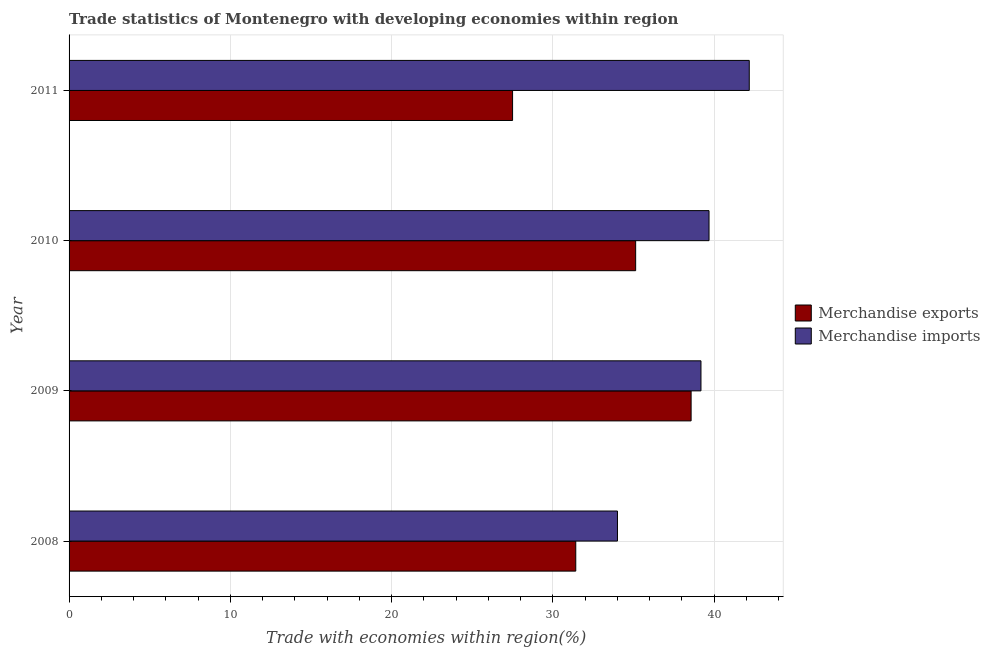How many groups of bars are there?
Ensure brevity in your answer.  4. Are the number of bars per tick equal to the number of legend labels?
Keep it short and to the point. Yes. In how many cases, is the number of bars for a given year not equal to the number of legend labels?
Keep it short and to the point. 0. What is the merchandise imports in 2008?
Your response must be concise. 34. Across all years, what is the maximum merchandise exports?
Your answer should be very brief. 38.57. Across all years, what is the minimum merchandise exports?
Make the answer very short. 27.5. In which year was the merchandise exports maximum?
Your answer should be compact. 2009. What is the total merchandise exports in the graph?
Your answer should be very brief. 132.61. What is the difference between the merchandise exports in 2008 and that in 2009?
Your response must be concise. -7.15. What is the difference between the merchandise imports in 2008 and the merchandise exports in 2010?
Your response must be concise. -1.13. What is the average merchandise exports per year?
Give a very brief answer. 33.15. In the year 2009, what is the difference between the merchandise imports and merchandise exports?
Offer a terse response. 0.61. In how many years, is the merchandise imports greater than 6 %?
Keep it short and to the point. 4. What is the ratio of the merchandise imports in 2010 to that in 2011?
Your answer should be very brief. 0.94. Is the difference between the merchandise exports in 2008 and 2009 greater than the difference between the merchandise imports in 2008 and 2009?
Provide a short and direct response. No. What is the difference between the highest and the second highest merchandise imports?
Ensure brevity in your answer.  2.5. What is the difference between the highest and the lowest merchandise exports?
Keep it short and to the point. 11.07. How many bars are there?
Provide a short and direct response. 8. How many years are there in the graph?
Make the answer very short. 4. What is the difference between two consecutive major ticks on the X-axis?
Your answer should be very brief. 10. Where does the legend appear in the graph?
Your answer should be compact. Center right. How many legend labels are there?
Ensure brevity in your answer.  2. What is the title of the graph?
Give a very brief answer. Trade statistics of Montenegro with developing economies within region. Does "Goods and services" appear as one of the legend labels in the graph?
Your answer should be very brief. No. What is the label or title of the X-axis?
Ensure brevity in your answer.  Trade with economies within region(%). What is the label or title of the Y-axis?
Provide a succinct answer. Year. What is the Trade with economies within region(%) of Merchandise exports in 2008?
Provide a succinct answer. 31.42. What is the Trade with economies within region(%) in Merchandise imports in 2008?
Give a very brief answer. 34. What is the Trade with economies within region(%) in Merchandise exports in 2009?
Provide a succinct answer. 38.57. What is the Trade with economies within region(%) in Merchandise imports in 2009?
Make the answer very short. 39.18. What is the Trade with economies within region(%) in Merchandise exports in 2010?
Offer a terse response. 35.13. What is the Trade with economies within region(%) in Merchandise imports in 2010?
Offer a terse response. 39.68. What is the Trade with economies within region(%) in Merchandise exports in 2011?
Your answer should be very brief. 27.5. What is the Trade with economies within region(%) in Merchandise imports in 2011?
Your answer should be compact. 42.17. Across all years, what is the maximum Trade with economies within region(%) of Merchandise exports?
Provide a succinct answer. 38.57. Across all years, what is the maximum Trade with economies within region(%) of Merchandise imports?
Make the answer very short. 42.17. Across all years, what is the minimum Trade with economies within region(%) in Merchandise exports?
Provide a short and direct response. 27.5. Across all years, what is the minimum Trade with economies within region(%) in Merchandise imports?
Your answer should be compact. 34. What is the total Trade with economies within region(%) of Merchandise exports in the graph?
Make the answer very short. 132.61. What is the total Trade with economies within region(%) of Merchandise imports in the graph?
Offer a terse response. 155.03. What is the difference between the Trade with economies within region(%) of Merchandise exports in 2008 and that in 2009?
Keep it short and to the point. -7.15. What is the difference between the Trade with economies within region(%) of Merchandise imports in 2008 and that in 2009?
Keep it short and to the point. -5.18. What is the difference between the Trade with economies within region(%) of Merchandise exports in 2008 and that in 2010?
Keep it short and to the point. -3.71. What is the difference between the Trade with economies within region(%) of Merchandise imports in 2008 and that in 2010?
Your response must be concise. -5.68. What is the difference between the Trade with economies within region(%) in Merchandise exports in 2008 and that in 2011?
Your answer should be very brief. 3.92. What is the difference between the Trade with economies within region(%) of Merchandise imports in 2008 and that in 2011?
Ensure brevity in your answer.  -8.17. What is the difference between the Trade with economies within region(%) of Merchandise exports in 2009 and that in 2010?
Offer a very short reply. 3.44. What is the difference between the Trade with economies within region(%) in Merchandise imports in 2009 and that in 2010?
Your response must be concise. -0.5. What is the difference between the Trade with economies within region(%) in Merchandise exports in 2009 and that in 2011?
Offer a very short reply. 11.07. What is the difference between the Trade with economies within region(%) of Merchandise imports in 2009 and that in 2011?
Provide a short and direct response. -2.99. What is the difference between the Trade with economies within region(%) in Merchandise exports in 2010 and that in 2011?
Provide a short and direct response. 7.63. What is the difference between the Trade with economies within region(%) in Merchandise imports in 2010 and that in 2011?
Offer a very short reply. -2.49. What is the difference between the Trade with economies within region(%) of Merchandise exports in 2008 and the Trade with economies within region(%) of Merchandise imports in 2009?
Keep it short and to the point. -7.76. What is the difference between the Trade with economies within region(%) in Merchandise exports in 2008 and the Trade with economies within region(%) in Merchandise imports in 2010?
Provide a succinct answer. -8.26. What is the difference between the Trade with economies within region(%) in Merchandise exports in 2008 and the Trade with economies within region(%) in Merchandise imports in 2011?
Give a very brief answer. -10.76. What is the difference between the Trade with economies within region(%) in Merchandise exports in 2009 and the Trade with economies within region(%) in Merchandise imports in 2010?
Keep it short and to the point. -1.11. What is the difference between the Trade with economies within region(%) in Merchandise exports in 2009 and the Trade with economies within region(%) in Merchandise imports in 2011?
Make the answer very short. -3.61. What is the difference between the Trade with economies within region(%) in Merchandise exports in 2010 and the Trade with economies within region(%) in Merchandise imports in 2011?
Give a very brief answer. -7.04. What is the average Trade with economies within region(%) of Merchandise exports per year?
Ensure brevity in your answer.  33.15. What is the average Trade with economies within region(%) of Merchandise imports per year?
Your answer should be compact. 38.76. In the year 2008, what is the difference between the Trade with economies within region(%) in Merchandise exports and Trade with economies within region(%) in Merchandise imports?
Give a very brief answer. -2.59. In the year 2009, what is the difference between the Trade with economies within region(%) of Merchandise exports and Trade with economies within region(%) of Merchandise imports?
Your response must be concise. -0.61. In the year 2010, what is the difference between the Trade with economies within region(%) of Merchandise exports and Trade with economies within region(%) of Merchandise imports?
Your answer should be compact. -4.55. In the year 2011, what is the difference between the Trade with economies within region(%) in Merchandise exports and Trade with economies within region(%) in Merchandise imports?
Your answer should be compact. -14.68. What is the ratio of the Trade with economies within region(%) of Merchandise exports in 2008 to that in 2009?
Provide a short and direct response. 0.81. What is the ratio of the Trade with economies within region(%) in Merchandise imports in 2008 to that in 2009?
Your answer should be compact. 0.87. What is the ratio of the Trade with economies within region(%) of Merchandise exports in 2008 to that in 2010?
Keep it short and to the point. 0.89. What is the ratio of the Trade with economies within region(%) of Merchandise imports in 2008 to that in 2010?
Make the answer very short. 0.86. What is the ratio of the Trade with economies within region(%) in Merchandise exports in 2008 to that in 2011?
Give a very brief answer. 1.14. What is the ratio of the Trade with economies within region(%) in Merchandise imports in 2008 to that in 2011?
Your response must be concise. 0.81. What is the ratio of the Trade with economies within region(%) of Merchandise exports in 2009 to that in 2010?
Your answer should be compact. 1.1. What is the ratio of the Trade with economies within region(%) in Merchandise imports in 2009 to that in 2010?
Ensure brevity in your answer.  0.99. What is the ratio of the Trade with economies within region(%) of Merchandise exports in 2009 to that in 2011?
Keep it short and to the point. 1.4. What is the ratio of the Trade with economies within region(%) of Merchandise imports in 2009 to that in 2011?
Provide a short and direct response. 0.93. What is the ratio of the Trade with economies within region(%) of Merchandise exports in 2010 to that in 2011?
Ensure brevity in your answer.  1.28. What is the ratio of the Trade with economies within region(%) of Merchandise imports in 2010 to that in 2011?
Your answer should be very brief. 0.94. What is the difference between the highest and the second highest Trade with economies within region(%) in Merchandise exports?
Keep it short and to the point. 3.44. What is the difference between the highest and the second highest Trade with economies within region(%) in Merchandise imports?
Your answer should be compact. 2.49. What is the difference between the highest and the lowest Trade with economies within region(%) in Merchandise exports?
Offer a very short reply. 11.07. What is the difference between the highest and the lowest Trade with economies within region(%) of Merchandise imports?
Keep it short and to the point. 8.17. 